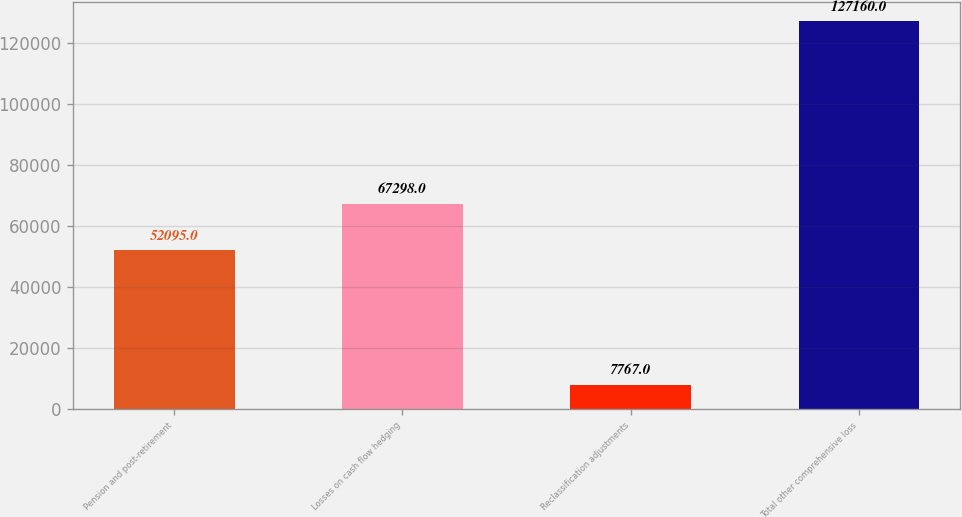Convert chart. <chart><loc_0><loc_0><loc_500><loc_500><bar_chart><fcel>Pension and post-retirement<fcel>Losses on cash flow hedging<fcel>Reclassification adjustments<fcel>Total other comprehensive loss<nl><fcel>52095<fcel>67298<fcel>7767<fcel>127160<nl></chart> 